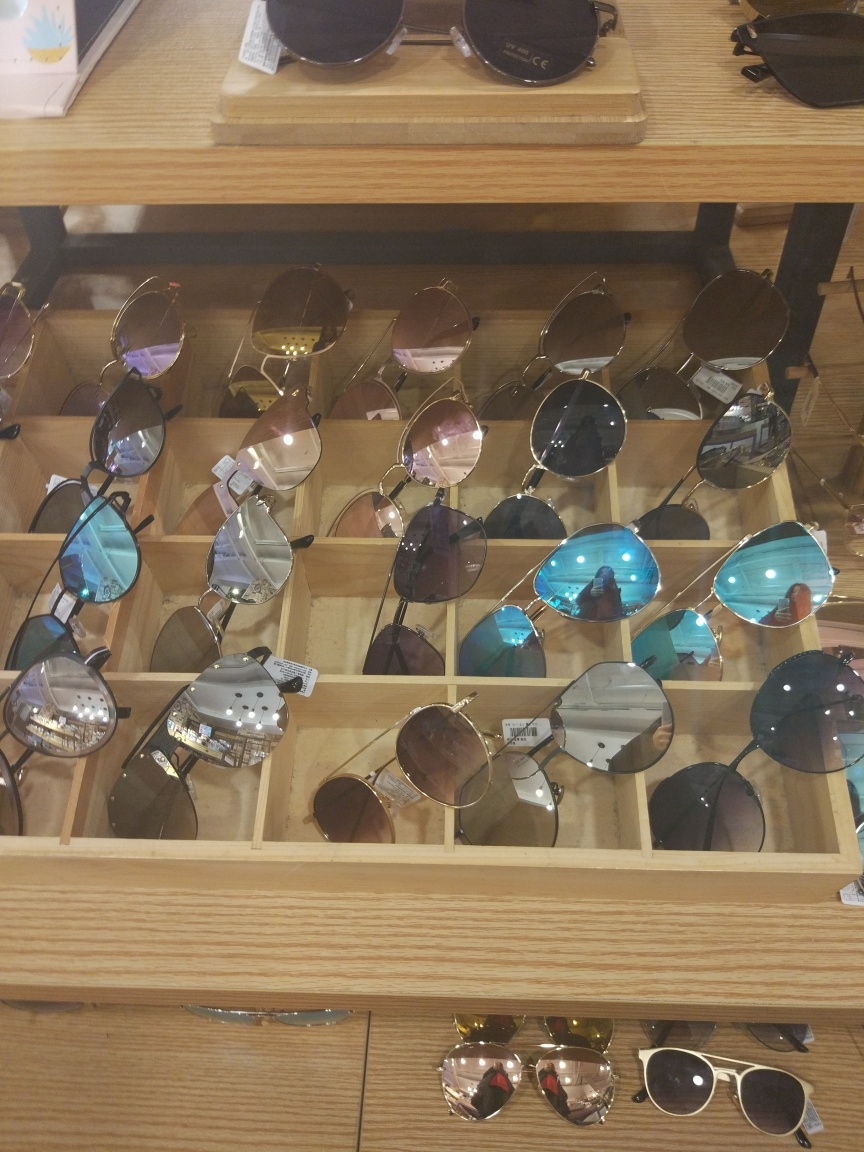Which pair would be best for a beach holiday, in your opinion? For a beach holiday, a pair with polarized lenses would be ideal to reduce glare from the water. A larger lens, such as the oversized style with tinted lenses seen on the second shelf from the top, might also provide more cover from the sun. 